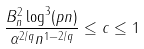Convert formula to latex. <formula><loc_0><loc_0><loc_500><loc_500>\frac { B _ { n } ^ { 2 } \log ^ { 3 } ( p n ) } { \alpha ^ { 2 / q } n ^ { 1 - 2 / q } } \leq c \leq 1</formula> 